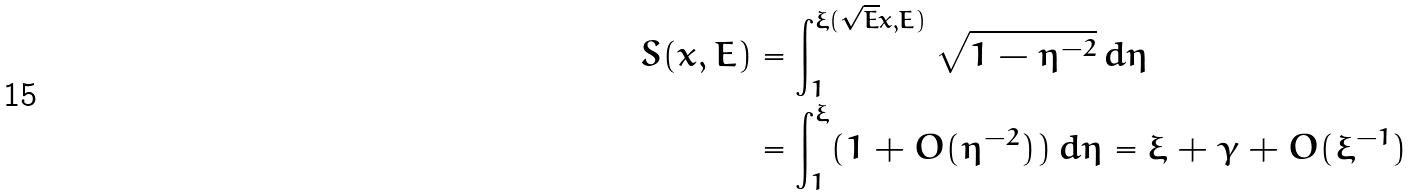<formula> <loc_0><loc_0><loc_500><loc_500>S ( x , E ) & = \int _ { 1 } ^ { \xi ( \sqrt { E } x , E ) } \sqrt { 1 - \eta ^ { - 2 } } \, d \eta \\ & = \int _ { 1 } ^ { \xi } ( 1 + O ( \eta ^ { - 2 } ) ) \, d \eta = \xi + \gamma + O ( \xi ^ { - 1 } )</formula> 